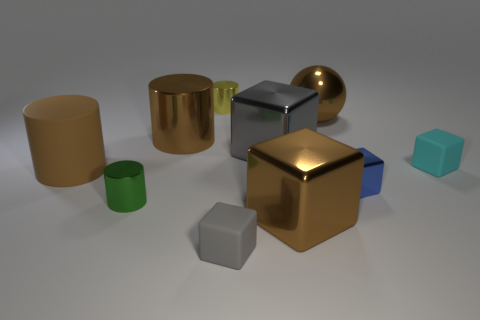Subtract all brown shiny blocks. How many blocks are left? 4 Subtract all brown cubes. How many cubes are left? 4 Subtract all red cubes. Subtract all red spheres. How many cubes are left? 5 Subtract all cylinders. How many objects are left? 6 Add 10 large blue objects. How many large blue objects exist? 10 Subtract 1 yellow cylinders. How many objects are left? 9 Subtract all large brown metal objects. Subtract all large yellow rubber spheres. How many objects are left? 7 Add 1 gray shiny objects. How many gray shiny objects are left? 2 